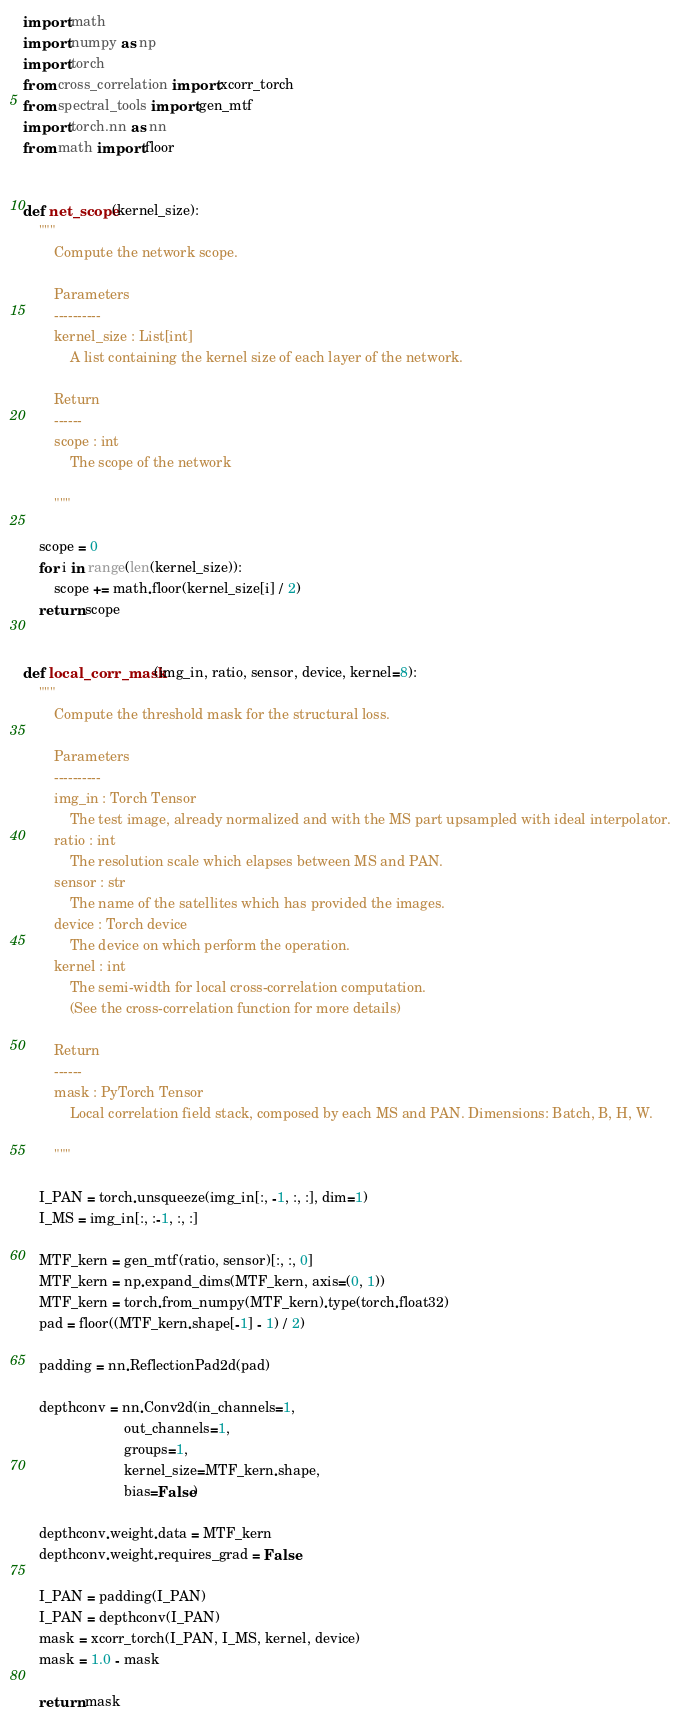<code> <loc_0><loc_0><loc_500><loc_500><_Python_>import math
import numpy as np
import torch
from cross_correlation import xcorr_torch
from spectral_tools import gen_mtf
import torch.nn as nn
from math import floor


def net_scope(kernel_size):
    """
        Compute the network scope.

        Parameters
        ----------
        kernel_size : List[int]
            A list containing the kernel size of each layer of the network.

        Return
        ------
        scope : int
            The scope of the network

        """

    scope = 0
    for i in range(len(kernel_size)):
        scope += math.floor(kernel_size[i] / 2)
    return scope


def local_corr_mask(img_in, ratio, sensor, device, kernel=8):
    """
        Compute the threshold mask for the structural loss.

        Parameters
        ----------
        img_in : Torch Tensor
            The test image, already normalized and with the MS part upsampled with ideal interpolator.
        ratio : int
            The resolution scale which elapses between MS and PAN.
        sensor : str
            The name of the satellites which has provided the images.
        device : Torch device
            The device on which perform the operation.
        kernel : int
            The semi-width for local cross-correlation computation.
            (See the cross-correlation function for more details)

        Return
        ------
        mask : PyTorch Tensor
            Local correlation field stack, composed by each MS and PAN. Dimensions: Batch, B, H, W.

        """

    I_PAN = torch.unsqueeze(img_in[:, -1, :, :], dim=1)
    I_MS = img_in[:, :-1, :, :]

    MTF_kern = gen_mtf(ratio, sensor)[:, :, 0]
    MTF_kern = np.expand_dims(MTF_kern, axis=(0, 1))
    MTF_kern = torch.from_numpy(MTF_kern).type(torch.float32)
    pad = floor((MTF_kern.shape[-1] - 1) / 2)

    padding = nn.ReflectionPad2d(pad)

    depthconv = nn.Conv2d(in_channels=1,
                          out_channels=1,
                          groups=1,
                          kernel_size=MTF_kern.shape,
                          bias=False)

    depthconv.weight.data = MTF_kern
    depthconv.weight.requires_grad = False

    I_PAN = padding(I_PAN)
    I_PAN = depthconv(I_PAN)
    mask = xcorr_torch(I_PAN, I_MS, kernel, device)
    mask = 1.0 - mask

    return mask
</code> 